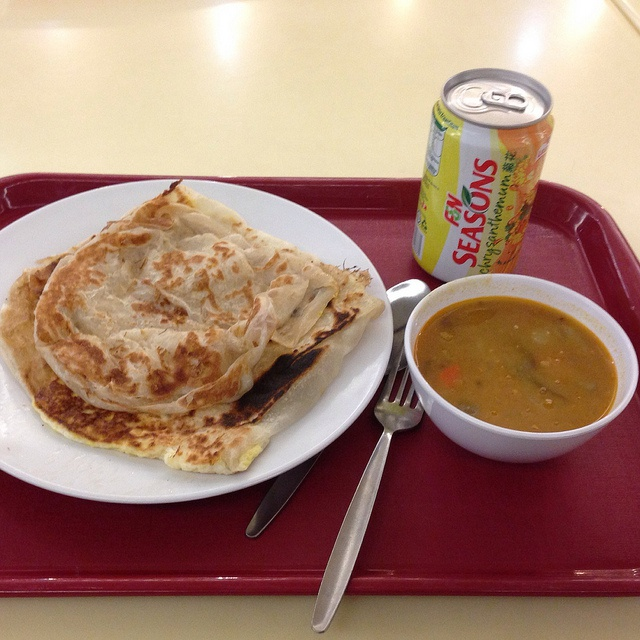Describe the objects in this image and their specific colors. I can see sandwich in tan, gray, and brown tones, bowl in tan, olive, maroon, darkgray, and gray tones, fork in tan, darkgray, gray, and black tones, and knife in tan, black, gray, and maroon tones in this image. 